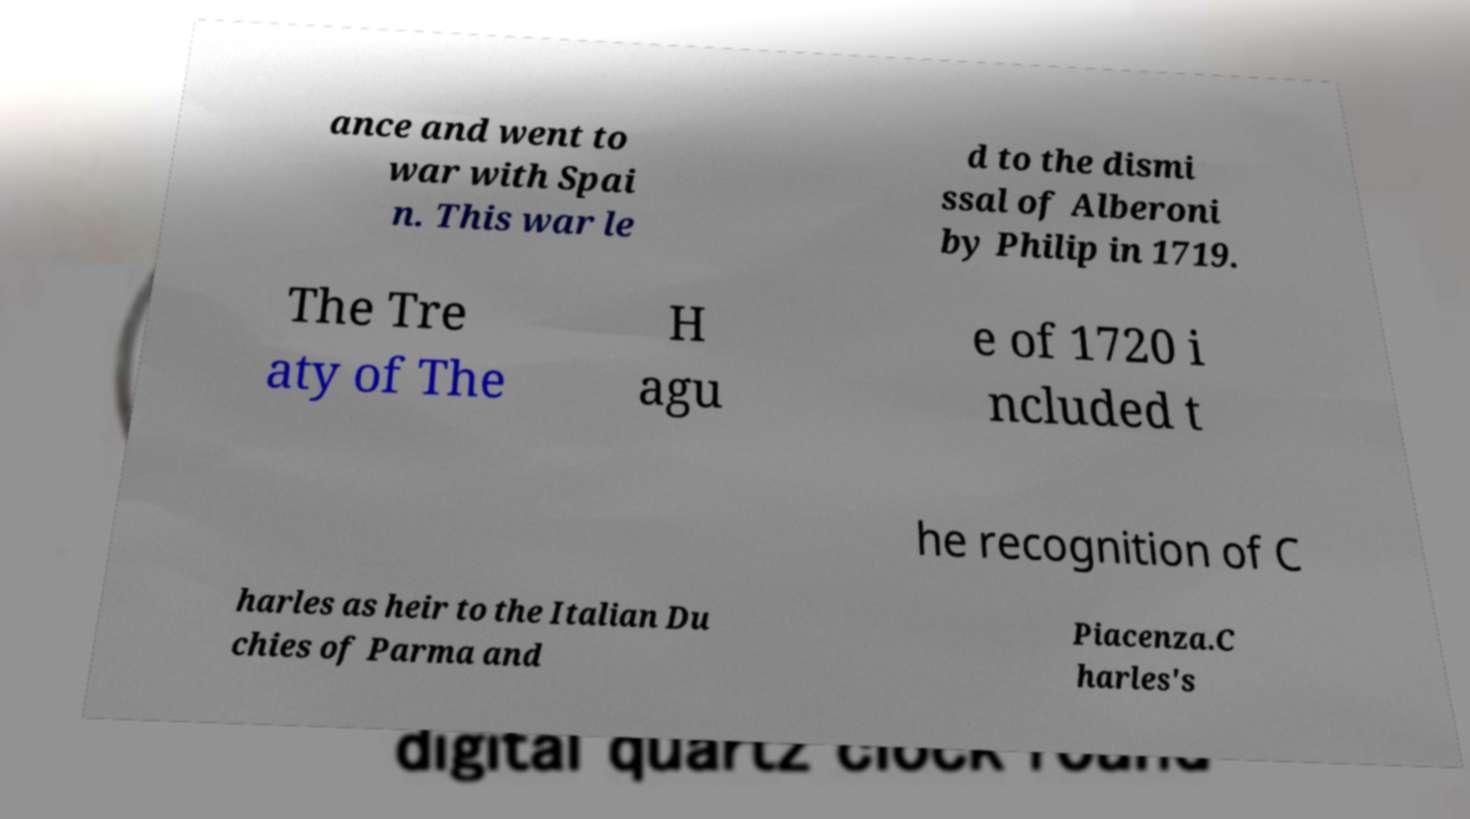Could you assist in decoding the text presented in this image and type it out clearly? ance and went to war with Spai n. This war le d to the dismi ssal of Alberoni by Philip in 1719. The Tre aty of The H agu e of 1720 i ncluded t he recognition of C harles as heir to the Italian Du chies of Parma and Piacenza.C harles's 